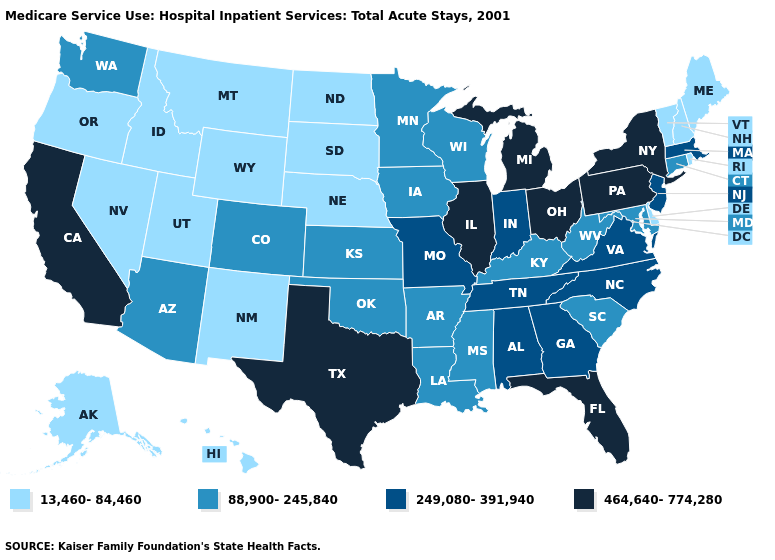What is the lowest value in the West?
Quick response, please. 13,460-84,460. What is the value of New Hampshire?
Concise answer only. 13,460-84,460. What is the highest value in the USA?
Short answer required. 464,640-774,280. What is the value of Massachusetts?
Keep it brief. 249,080-391,940. Name the states that have a value in the range 88,900-245,840?
Keep it brief. Arizona, Arkansas, Colorado, Connecticut, Iowa, Kansas, Kentucky, Louisiana, Maryland, Minnesota, Mississippi, Oklahoma, South Carolina, Washington, West Virginia, Wisconsin. What is the value of Minnesota?
Concise answer only. 88,900-245,840. What is the value of Nebraska?
Give a very brief answer. 13,460-84,460. Which states hav the highest value in the South?
Keep it brief. Florida, Texas. Does West Virginia have a higher value than Vermont?
Quick response, please. Yes. How many symbols are there in the legend?
Quick response, please. 4. What is the value of Oklahoma?
Keep it brief. 88,900-245,840. Does Washington have the highest value in the USA?
Concise answer only. No. What is the value of Ohio?
Keep it brief. 464,640-774,280. What is the value of Louisiana?
Quick response, please. 88,900-245,840. What is the value of Maryland?
Short answer required. 88,900-245,840. 